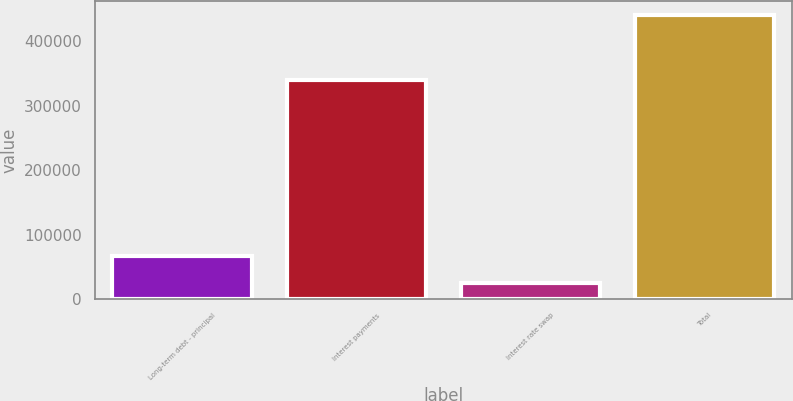Convert chart. <chart><loc_0><loc_0><loc_500><loc_500><bar_chart><fcel>Long-term debt - principal<fcel>Interest payments<fcel>Interest rate swap<fcel>Total<nl><fcel>66114.4<fcel>339230<fcel>24522<fcel>440446<nl></chart> 